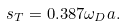<formula> <loc_0><loc_0><loc_500><loc_500>s _ { T } = 0 . 3 8 7 \omega _ { D } a .</formula> 